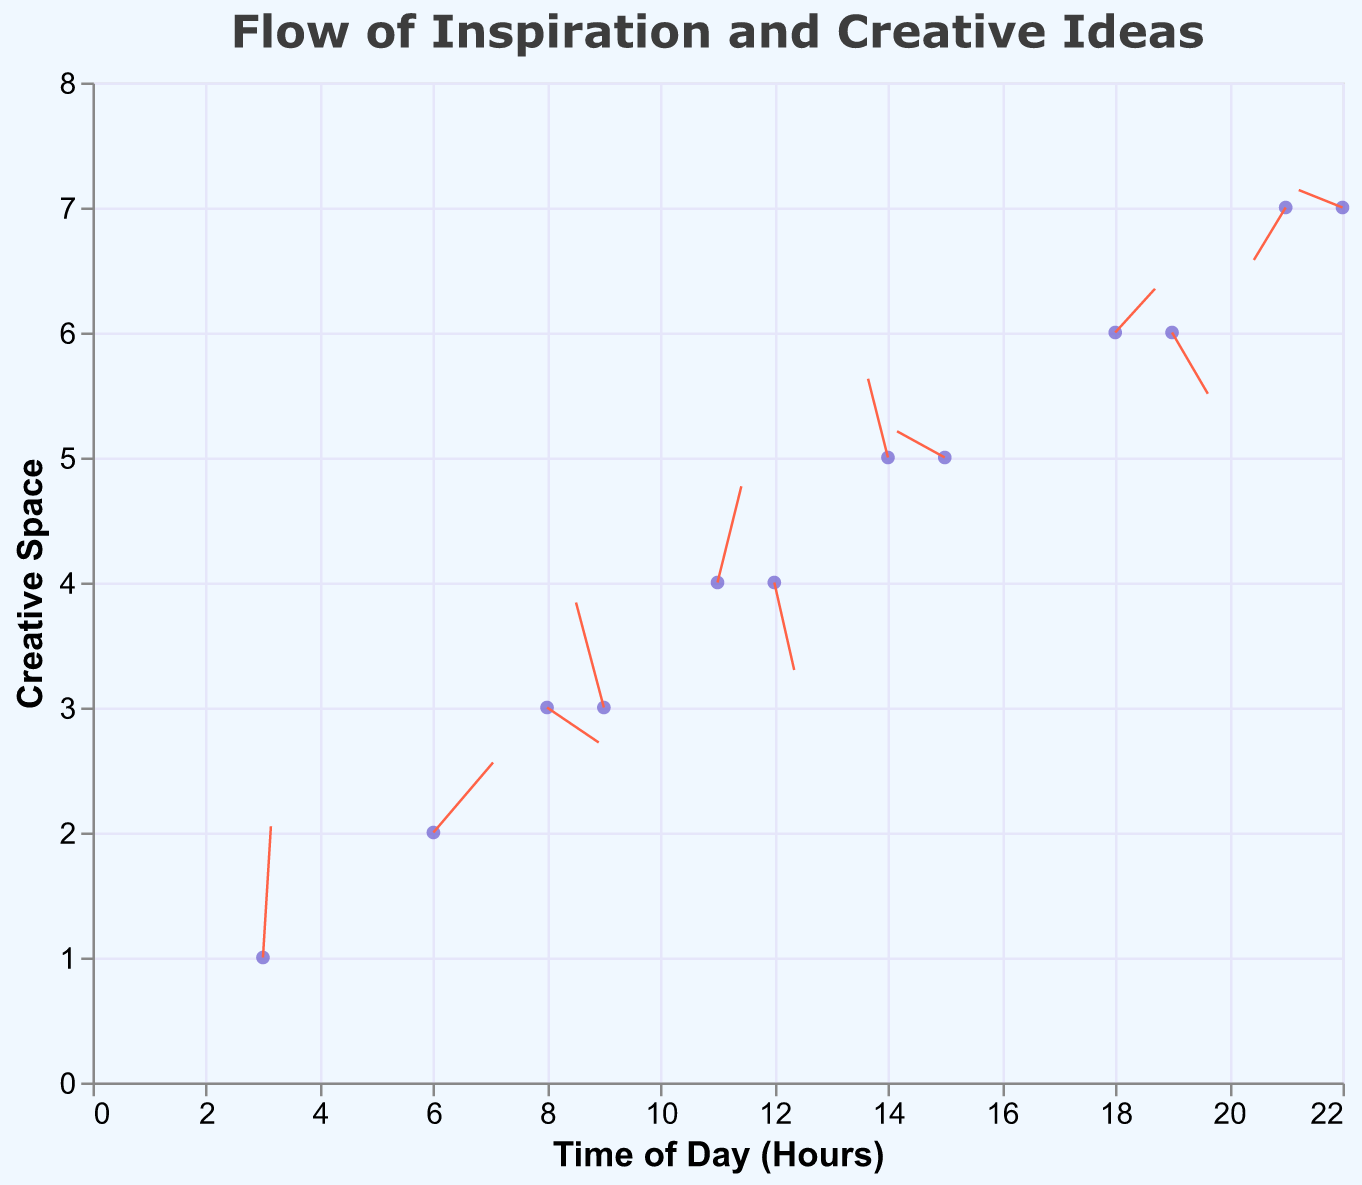What is the title of the plot? The title can be found at the top of the plot and is usually in a prominent font to indicate the subject of the visualization. In this case, it reads "Flow of Inspiration and Creative Ideas" in a font that stands out.
Answer: Flow of Inspiration and Creative Ideas What do the x and y axes represent? The x-axis represents "Time of Day (Hours)" which can be seen by the label along the bottom of the plot, while the y-axis represents "Creative Space", indicated by the label along the left side of the plot.
Answer: Time of Day (Hours) and Creative Space How many data points are displayed in the plot? By counting the individual points (blue dots) visible in the plot, which represent different times and spaces of recording creative flow, we can determine the total number of data points.
Answer: 12 At which time of day does the flow of inspiration have its strongest magnitude? To find the time with the strongest flow, we look for the vector (arrow) with the largest magnitude value. Magnitude values can be inferred from the length of the arrows if not directly labeled, and by checking, we identify the time of day corresponding to this.
Answer: 15 hours At the creative space level 7, what are the predominant directions of the flow of inspiration at different times? By focusing on the arrows only in the y value equal to 7, we evaluate their directions: at 21 hours the flow has a vector pointing down-left, and at 22 hours, it points slightly left and up.
Answer: Down-left at 21 hours and Left-up at 22 hours What is the direction and magnitude of the flow at x=14 and y=5? At these coordinates, the arrow points up and slightly to the left with the vector components u = -0.5 and v = 0.9. The magnitude can be inferred based on the visualization or given data (here it was provided as 0.8).
Answer: Up-left, 0.8 How does the creative flow change from x=9 to x=12? By observing the arrows at x=9 and x=12, we see the direction changes from pointing upwards and slightly to the right at 9 hours (u = -0.7, v = 1.2) to pointing downwards at 12 hours (u = 0.5, v = -1.0). The flow goes from rising to declining in space.
Answer: Upward to downward At which time does the flow point primarily to the right? We need to identify the arrow where the primary component (u) is positive and has a higher magnitude compared to the vertical component (v). At 6 hours (u = 1.5, v = 0.8), the arrow points primarily to the right.
Answer: 6 hours Which time of the day has the most complex flow pattern, indicated by the highest magnitude? By identifying the magnitude values from the data, the highest value indicates the most complex flow. Here at 15 hours, the flow has the highest magnitude (1.3), making it the most intricate.
Answer: 15 hours 